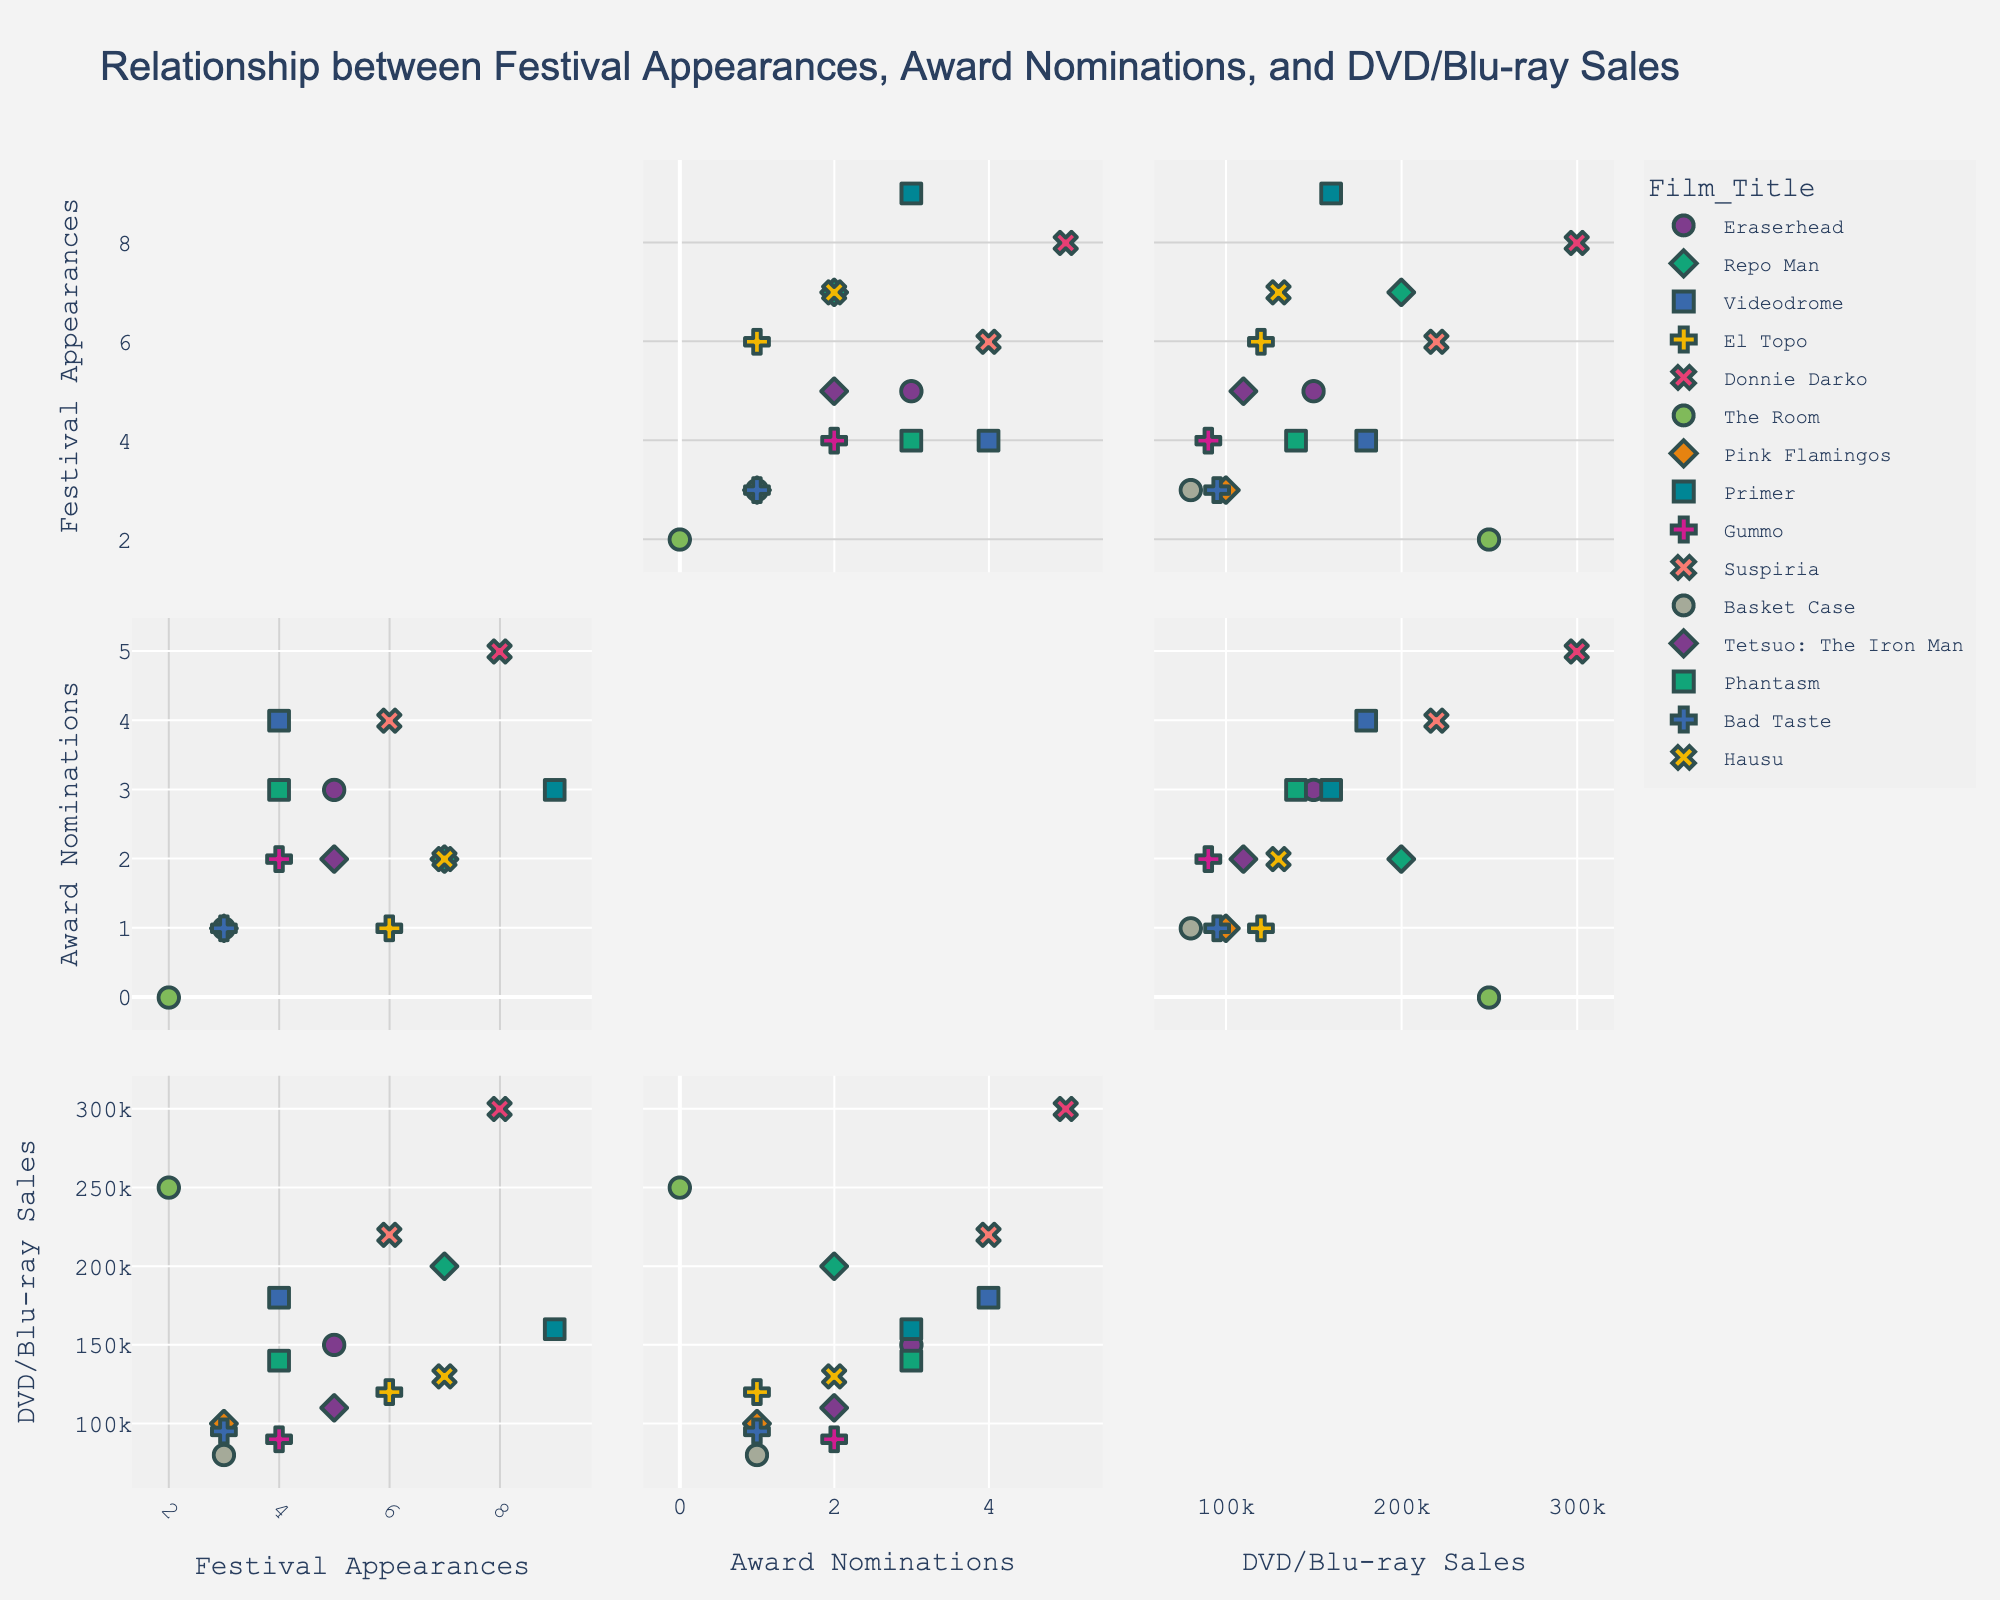What is the title of the plot? Look at the main title located at the top of the figure. It reads: "Protobuf Message Sizes and Compression Ratios".
Answer: Protobuf Message Sizes and Compression Ratios Which programming language has the highest compression ratio for the 'string' data type? Find the markers corresponding to the 'string' data type and identify which programming language has the highest y-value (compression ratio). Rust with a compression ratio of 2.0 has the highest.
Answer: Rust Which language has the smallest message size for the 'repeated_int32' data type? Look for the 'repeated_int32' markers along the x-axis in the subplots and identify the programming language with the smallest x-value (message size). Rust has a message size of 36 bytes for 'repeated_int32'.
Answer: Rust How many languages are represented in total? Check the legend on the right side of the figure where each language is listed with a colored symbol. Count the number of unique languages. There are six languages represented: Go, Java, Python, Rust, C++, and Python.
Answer: Six What is the average compression ratio of the 'repeated_int32' data type across all languages? Locate the 'repeated_int32' data points, note their compression ratios, and calculate the average: (2.5 + 2.3 + 2.6 + 2.7 + 2.4)/5 = 2.5.
Answer: 2.5 Which data type has the same compression ratio across all programming languages? Scan through the markers for different data types and identify which data type has markers all aligned horizontally at a single y-value. The 'int32' data type has the same compression ratio of 1.0 across all languages.
Answer: int32 Among Go, Java, and Python, which has the smallest message size for the 'string' data type? Locate the 'string' data type markers for Go, Java, and Python and compare their x-values. Python has the smallest message size of 22 bytes for the 'string' data type.
Answer: Python Is there any programming language that has a compression ratio greater than 2 for the 'string' data type? Check the 'string' data type markers and see if any exceed a compression ratio (y-value) of 2. Only Rust has a compression ratio greater than 2 for the 'string' data type.
Answer: Yes, Rust Which data type has the most significant variation in compression ratios across all programming languages? Observe and compare the spread of the markers for each data type across the subplots. The 'string' data type shows the most considerable variation in compression ratios from around 1.6 to 2.0.
Answer: string What programming language has the maximum spread in message sizes for 'repeated_int32' data type and why? Check the range of x-values for 'repeated_int32' data type for each language. Python has the maximum spread from minimum 36 bytes to maximum 44 bytes for 'repeated_int32' data type.
Answer: Python 